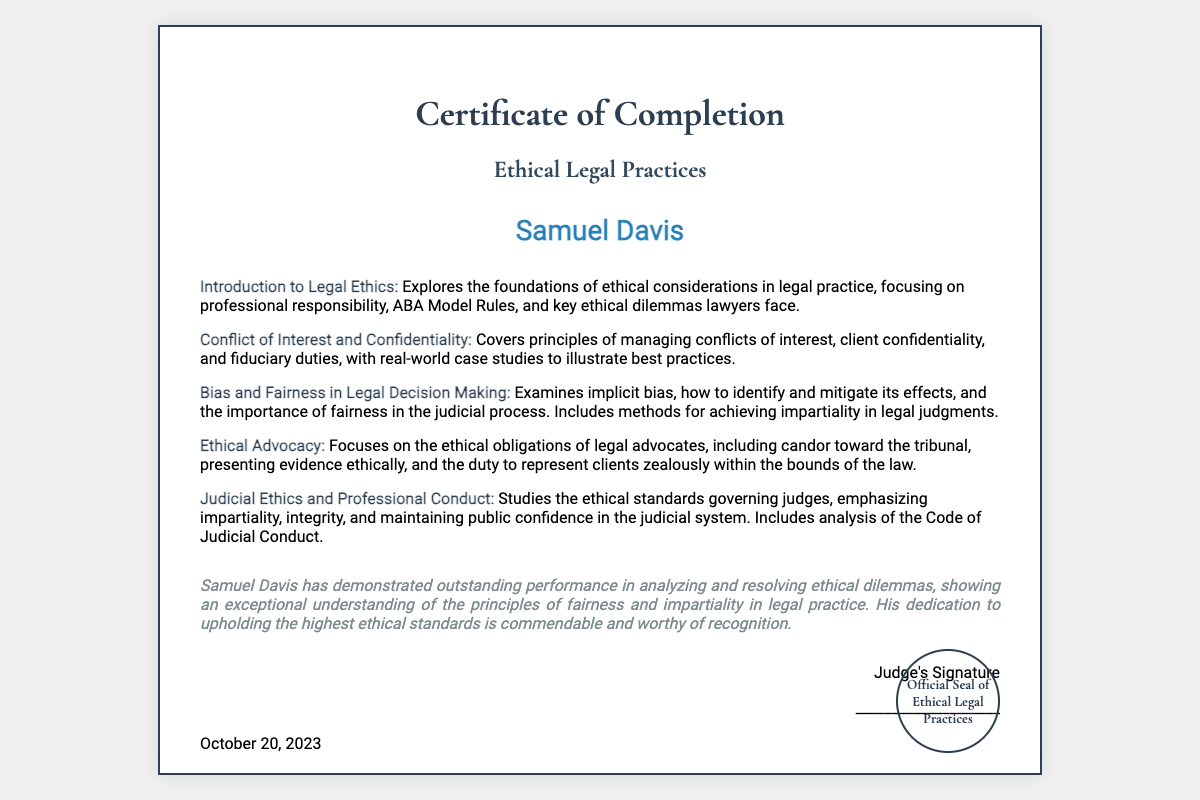What is the title of the certificate? The title of the certificate is prominently stated at the top of the document.
Answer: Certificate of Completion Who is the recipient of the certificate? The recipient's name is clearly displayed in the center of the document.
Answer: Samuel Davis When was the certificate issued? The date on the document indicates when the certificate was issued.
Answer: October 20, 2023 Which module focuses on conflicts of interest? The document lists various modules, including one specifically addressing conflicts of interest.
Answer: Conflict of Interest and Confidentiality What is highlighted in the commendation? The commendation emphasizes the recipient's performance and understanding of ethical principles.
Answer: Outstanding performance in analyzing and resolving ethical dilemmas How many modules are included in the course? The number of modules is indicated by the distinct entries listed in the document.
Answer: Five What is the focus of the "Bias and Fairness in Legal Decision Making" module? The description of this module outlines its coverage regarding bias and fairness.
Answer: Implicit bias and fairness in judicial process What does the judge's commendation specifically recognize? The commendation acknowledges a particular quality or performance of the recipient.
Answer: Exceptional understanding of the principles of fairness What kind of seal is mentioned in the document? The final section of the certificate refers to a specific type of seal associated with the certificate.
Answer: Official Seal of Ethical Legal Practices 